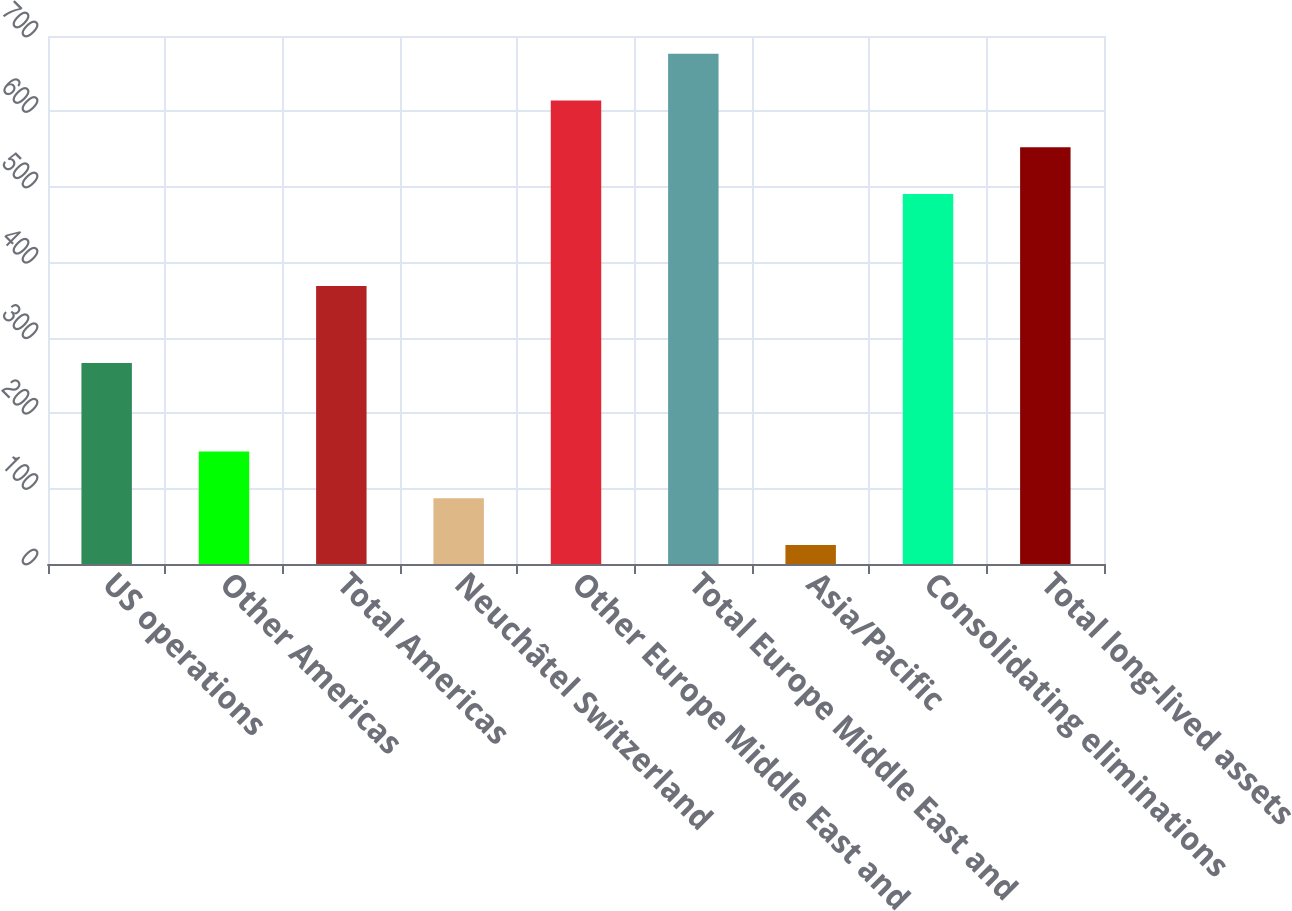Convert chart. <chart><loc_0><loc_0><loc_500><loc_500><bar_chart><fcel>US operations<fcel>Other Americas<fcel>Total Americas<fcel>Neuchâtel Switzerland<fcel>Other Europe Middle East and<fcel>Total Europe Middle East and<fcel>Asia/Pacific<fcel>Consolidating eliminations<fcel>Total long-lived assets<nl><fcel>266.4<fcel>149.12<fcel>368.5<fcel>87.16<fcel>614.42<fcel>676.38<fcel>25.2<fcel>490.5<fcel>552.46<nl></chart> 